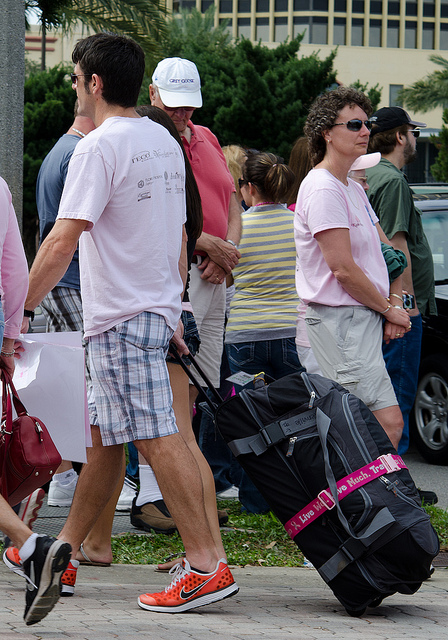Please transcribe the text in this image. Tra Live Live 